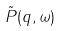Convert formula to latex. <formula><loc_0><loc_0><loc_500><loc_500>\tilde { P } ( q , \omega )</formula> 